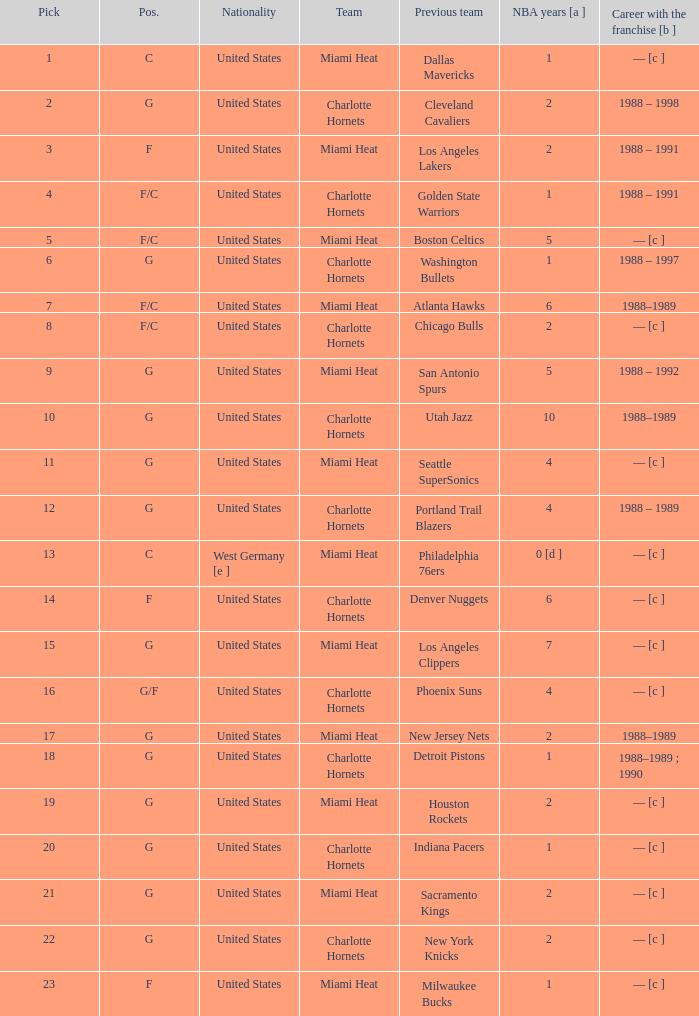What is the squad of the athlete who was formerly on the indiana pacers? Charlotte Hornets. 